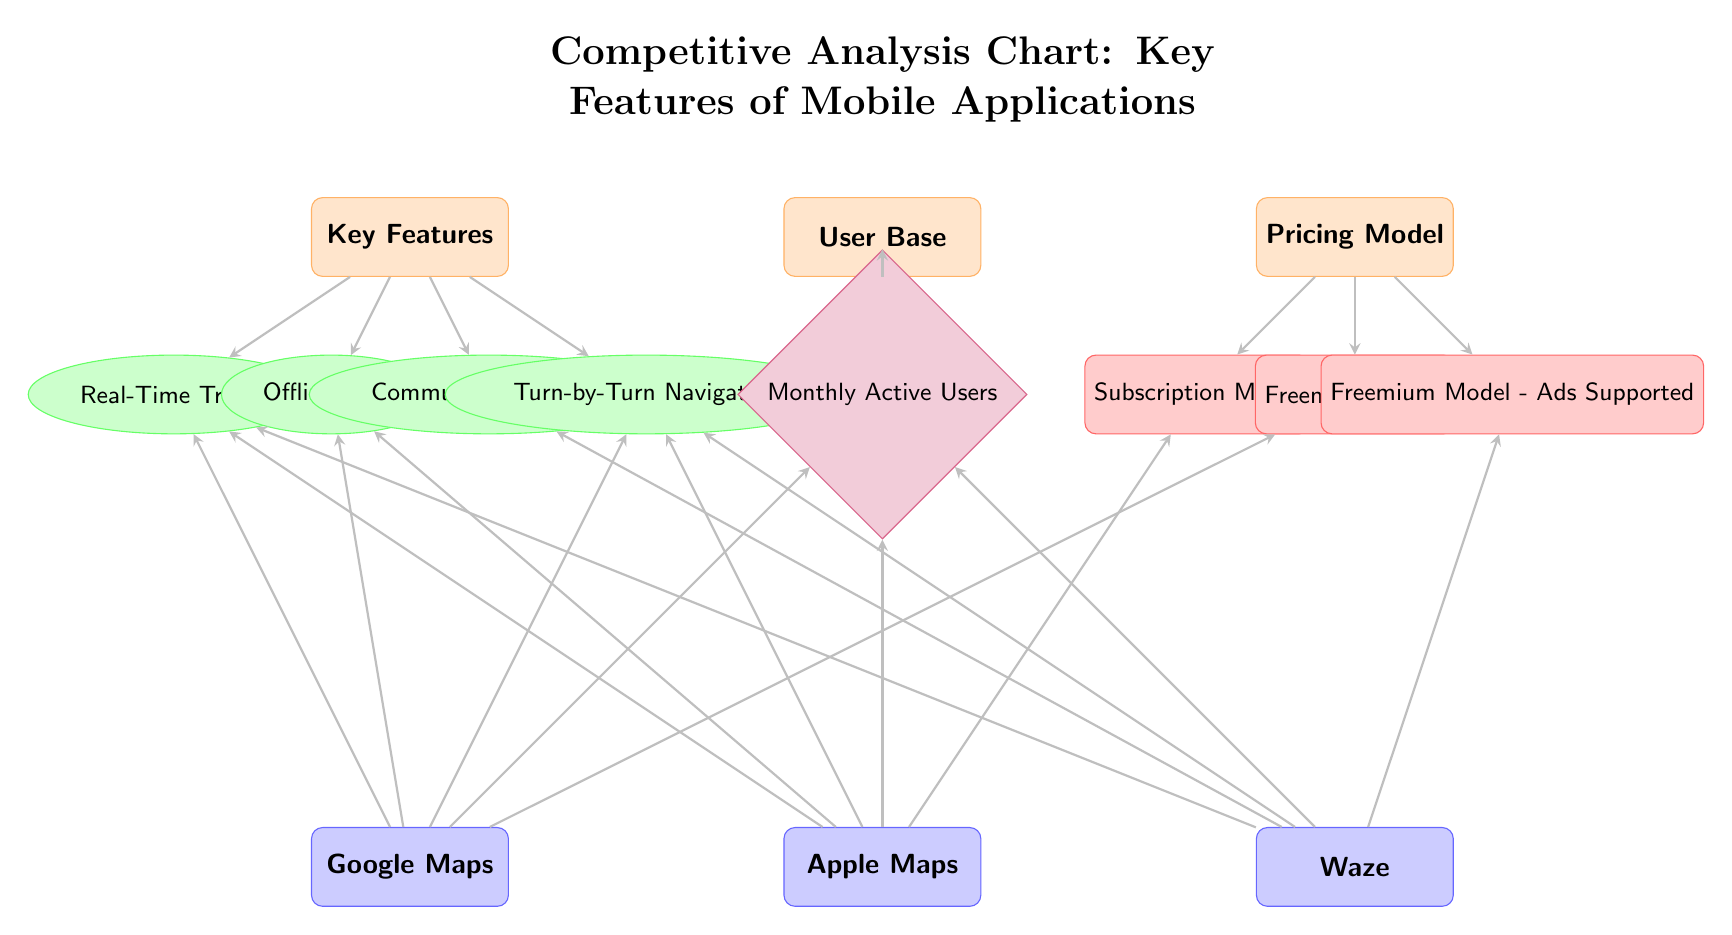What are the key features listed in the diagram? The diagram includes four key features: Real-Time Traffic, Offline Maps, Community Reporting, and Turn-by-Turn Navigation. This information can be found under the "Key Features" category where the features are directly linked.
Answer: Real-Time Traffic, Offline Maps, Community Reporting, Turn-by-Turn Navigation Which applications are compared in this analysis? The diagram lists three applications: Google Maps, Apple Maps, and Waze. This information can be found in the "Entities" section at the bottom of the diagram.
Answer: Google Maps, Apple Maps, Waze What pricing model does Apple Maps use? The connection from Apple Maps to "Subscription Model" indicates that Apple Maps uses this pricing method. We follow the arrow from Apple Maps to the Pricing Model category, where the corresponding model is distinctly labeled.
Answer: Subscription Model How many features are associated with Waze? Waze is associated with four features: Real-Time Traffic, Community Reporting, Turn-by-Turn Navigation, and is also linked to Monthly Active Users, leading to a total of four unique connections indicating these features.
Answer: Four Which feature is unique to Waze compared to the other applications? The diagram shows that Community Reporting is connected only to Waze, whereas the other features connect to multiple applications. Therefore, this feature is unique and distinguishes Waze from the others.
Answer: Community Reporting What is the connection between the User Base and Monthly Active Users? The arrow from the User Base to Monthly Active Users indicates that the user base is measured in terms of Monthly Active Users, establishing a relationship between the two concepts in the diagram.
Answer: Monthly Active Users How many pricing models are depicted in the chart? The diagram illustrates three unique pricing models: Subscription Model, Freemium Model, and Freemium Model - Ads Supported, which provides a discrete count of models listed within the Pricing Model category.
Answer: Three Which application is linked to the Freemium Model - Ads Supported? The positioning shows that the Freemium Model - Ads Supported is only connected to Google Maps and Waze, which can be verified by tracing arrows from those entities, confirming this relationship.
Answer: Waze What distinguishes Google Maps from Apple Maps regarding key features? Google Maps does not include a direct link to the Subscription Model but utilizes the Freemium Model; thus, it distinguishes itself from Apple Maps, which uses a Subscription Model. Additionally, all the features but the Community Reporting connect to Google Maps.
Answer: Freemium Model 